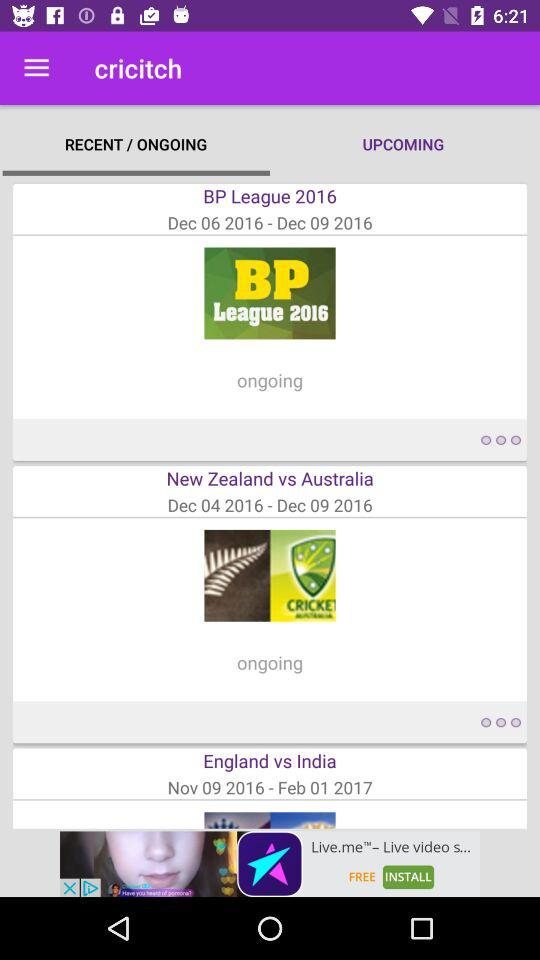What is the end date of the "New Zealand" vs. "Australia" series? The end date is December 9, 2016. 